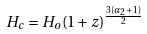<formula> <loc_0><loc_0><loc_500><loc_500>H _ { c } = H _ { o } ( 1 + z ) ^ { \frac { 3 ( \alpha _ { 2 } + 1 ) } { 2 } }</formula> 